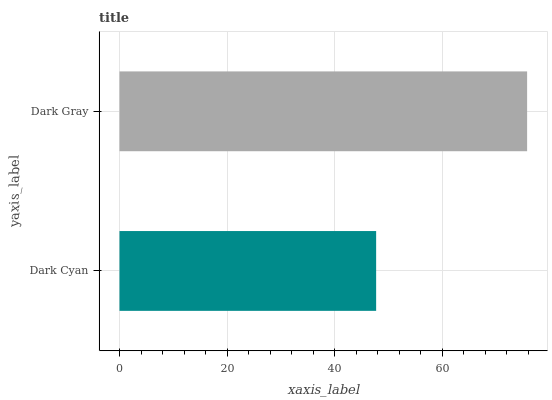Is Dark Cyan the minimum?
Answer yes or no. Yes. Is Dark Gray the maximum?
Answer yes or no. Yes. Is Dark Gray the minimum?
Answer yes or no. No. Is Dark Gray greater than Dark Cyan?
Answer yes or no. Yes. Is Dark Cyan less than Dark Gray?
Answer yes or no. Yes. Is Dark Cyan greater than Dark Gray?
Answer yes or no. No. Is Dark Gray less than Dark Cyan?
Answer yes or no. No. Is Dark Gray the high median?
Answer yes or no. Yes. Is Dark Cyan the low median?
Answer yes or no. Yes. Is Dark Cyan the high median?
Answer yes or no. No. Is Dark Gray the low median?
Answer yes or no. No. 